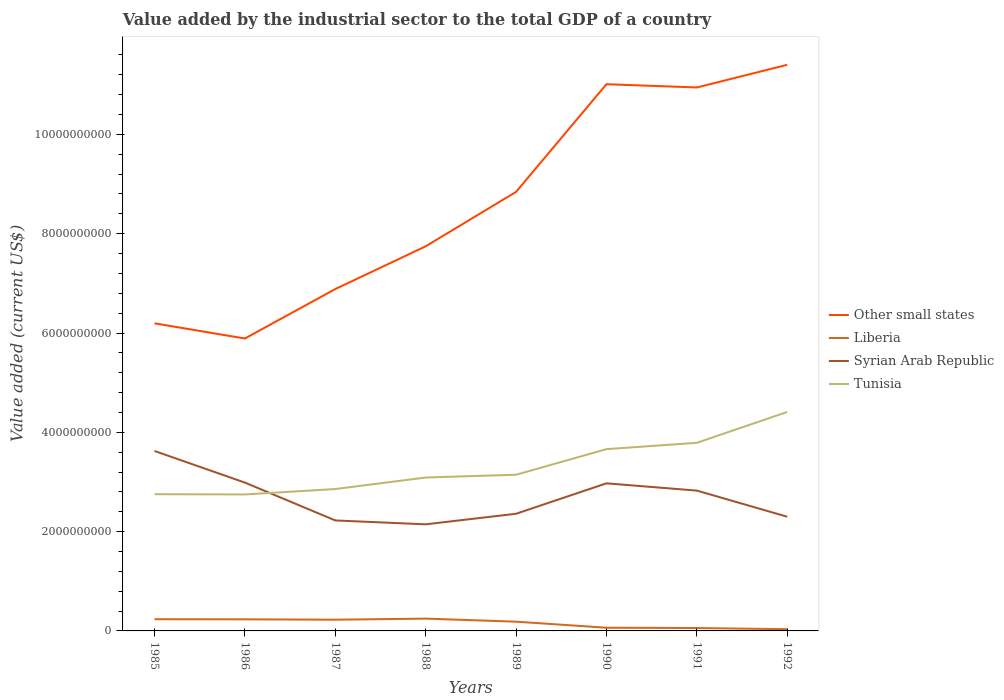How many different coloured lines are there?
Your response must be concise. 4. Does the line corresponding to Liberia intersect with the line corresponding to Syrian Arab Republic?
Your response must be concise. No. Across all years, what is the maximum value added by the industrial sector to the total GDP in Other small states?
Offer a very short reply. 5.89e+09. What is the total value added by the industrial sector to the total GDP in Syrian Arab Republic in the graph?
Your response must be concise. -8.26e+08. What is the difference between the highest and the second highest value added by the industrial sector to the total GDP in Liberia?
Make the answer very short. 2.13e+08. Is the value added by the industrial sector to the total GDP in Tunisia strictly greater than the value added by the industrial sector to the total GDP in Syrian Arab Republic over the years?
Offer a terse response. No. What is the difference between two consecutive major ticks on the Y-axis?
Give a very brief answer. 2.00e+09. Does the graph contain any zero values?
Offer a terse response. No. Does the graph contain grids?
Ensure brevity in your answer.  No. Where does the legend appear in the graph?
Your answer should be compact. Center right. How many legend labels are there?
Your answer should be compact. 4. How are the legend labels stacked?
Offer a terse response. Vertical. What is the title of the graph?
Offer a very short reply. Value added by the industrial sector to the total GDP of a country. What is the label or title of the X-axis?
Ensure brevity in your answer.  Years. What is the label or title of the Y-axis?
Provide a short and direct response. Value added (current US$). What is the Value added (current US$) in Other small states in 1985?
Offer a very short reply. 6.19e+09. What is the Value added (current US$) of Liberia in 1985?
Your response must be concise. 2.36e+08. What is the Value added (current US$) in Syrian Arab Republic in 1985?
Offer a very short reply. 3.62e+09. What is the Value added (current US$) in Tunisia in 1985?
Offer a terse response. 2.75e+09. What is the Value added (current US$) of Other small states in 1986?
Your answer should be very brief. 5.89e+09. What is the Value added (current US$) in Liberia in 1986?
Keep it short and to the point. 2.34e+08. What is the Value added (current US$) of Syrian Arab Republic in 1986?
Give a very brief answer. 2.99e+09. What is the Value added (current US$) in Tunisia in 1986?
Keep it short and to the point. 2.75e+09. What is the Value added (current US$) in Other small states in 1987?
Your response must be concise. 6.89e+09. What is the Value added (current US$) in Liberia in 1987?
Provide a short and direct response. 2.26e+08. What is the Value added (current US$) in Syrian Arab Republic in 1987?
Keep it short and to the point. 2.23e+09. What is the Value added (current US$) of Tunisia in 1987?
Provide a short and direct response. 2.86e+09. What is the Value added (current US$) of Other small states in 1988?
Your answer should be very brief. 7.75e+09. What is the Value added (current US$) of Liberia in 1988?
Provide a short and direct response. 2.48e+08. What is the Value added (current US$) of Syrian Arab Republic in 1988?
Make the answer very short. 2.15e+09. What is the Value added (current US$) in Tunisia in 1988?
Provide a short and direct response. 3.09e+09. What is the Value added (current US$) of Other small states in 1989?
Give a very brief answer. 8.84e+09. What is the Value added (current US$) of Liberia in 1989?
Offer a very short reply. 1.86e+08. What is the Value added (current US$) of Syrian Arab Republic in 1989?
Your response must be concise. 2.36e+09. What is the Value added (current US$) of Tunisia in 1989?
Offer a terse response. 3.15e+09. What is the Value added (current US$) in Other small states in 1990?
Ensure brevity in your answer.  1.10e+1. What is the Value added (current US$) of Liberia in 1990?
Your answer should be compact. 6.46e+07. What is the Value added (current US$) of Syrian Arab Republic in 1990?
Keep it short and to the point. 2.97e+09. What is the Value added (current US$) of Tunisia in 1990?
Ensure brevity in your answer.  3.66e+09. What is the Value added (current US$) in Other small states in 1991?
Provide a succinct answer. 1.09e+1. What is the Value added (current US$) in Liberia in 1991?
Keep it short and to the point. 5.83e+07. What is the Value added (current US$) in Syrian Arab Republic in 1991?
Give a very brief answer. 2.83e+09. What is the Value added (current US$) of Tunisia in 1991?
Ensure brevity in your answer.  3.79e+09. What is the Value added (current US$) of Other small states in 1992?
Your answer should be very brief. 1.14e+1. What is the Value added (current US$) of Liberia in 1992?
Keep it short and to the point. 3.49e+07. What is the Value added (current US$) in Syrian Arab Republic in 1992?
Provide a short and direct response. 2.30e+09. What is the Value added (current US$) of Tunisia in 1992?
Provide a succinct answer. 4.41e+09. Across all years, what is the maximum Value added (current US$) of Other small states?
Ensure brevity in your answer.  1.14e+1. Across all years, what is the maximum Value added (current US$) in Liberia?
Your response must be concise. 2.48e+08. Across all years, what is the maximum Value added (current US$) of Syrian Arab Republic?
Make the answer very short. 3.62e+09. Across all years, what is the maximum Value added (current US$) of Tunisia?
Provide a short and direct response. 4.41e+09. Across all years, what is the minimum Value added (current US$) of Other small states?
Ensure brevity in your answer.  5.89e+09. Across all years, what is the minimum Value added (current US$) of Liberia?
Offer a very short reply. 3.49e+07. Across all years, what is the minimum Value added (current US$) in Syrian Arab Republic?
Ensure brevity in your answer.  2.15e+09. Across all years, what is the minimum Value added (current US$) in Tunisia?
Your response must be concise. 2.75e+09. What is the total Value added (current US$) of Other small states in the graph?
Ensure brevity in your answer.  6.89e+1. What is the total Value added (current US$) in Liberia in the graph?
Make the answer very short. 1.29e+09. What is the total Value added (current US$) of Syrian Arab Republic in the graph?
Give a very brief answer. 2.14e+1. What is the total Value added (current US$) in Tunisia in the graph?
Your response must be concise. 2.65e+1. What is the difference between the Value added (current US$) in Other small states in 1985 and that in 1986?
Provide a short and direct response. 3.06e+08. What is the difference between the Value added (current US$) in Liberia in 1985 and that in 1986?
Your response must be concise. 2.39e+06. What is the difference between the Value added (current US$) in Syrian Arab Republic in 1985 and that in 1986?
Make the answer very short. 6.37e+08. What is the difference between the Value added (current US$) in Tunisia in 1985 and that in 1986?
Your response must be concise. 4.62e+06. What is the difference between the Value added (current US$) of Other small states in 1985 and that in 1987?
Offer a terse response. -6.90e+08. What is the difference between the Value added (current US$) in Liberia in 1985 and that in 1987?
Your response must be concise. 9.81e+06. What is the difference between the Value added (current US$) in Syrian Arab Republic in 1985 and that in 1987?
Keep it short and to the point. 1.40e+09. What is the difference between the Value added (current US$) of Tunisia in 1985 and that in 1987?
Keep it short and to the point. -1.04e+08. What is the difference between the Value added (current US$) of Other small states in 1985 and that in 1988?
Offer a terse response. -1.55e+09. What is the difference between the Value added (current US$) in Liberia in 1985 and that in 1988?
Provide a short and direct response. -1.18e+07. What is the difference between the Value added (current US$) in Syrian Arab Republic in 1985 and that in 1988?
Keep it short and to the point. 1.48e+09. What is the difference between the Value added (current US$) of Tunisia in 1985 and that in 1988?
Offer a very short reply. -3.36e+08. What is the difference between the Value added (current US$) of Other small states in 1985 and that in 1989?
Provide a short and direct response. -2.65e+09. What is the difference between the Value added (current US$) in Liberia in 1985 and that in 1989?
Ensure brevity in your answer.  4.98e+07. What is the difference between the Value added (current US$) of Syrian Arab Republic in 1985 and that in 1989?
Provide a succinct answer. 1.26e+09. What is the difference between the Value added (current US$) of Tunisia in 1985 and that in 1989?
Offer a very short reply. -3.92e+08. What is the difference between the Value added (current US$) in Other small states in 1985 and that in 1990?
Give a very brief answer. -4.82e+09. What is the difference between the Value added (current US$) of Liberia in 1985 and that in 1990?
Your answer should be compact. 1.71e+08. What is the difference between the Value added (current US$) of Syrian Arab Republic in 1985 and that in 1990?
Provide a short and direct response. 6.52e+08. What is the difference between the Value added (current US$) in Tunisia in 1985 and that in 1990?
Offer a very short reply. -9.08e+08. What is the difference between the Value added (current US$) in Other small states in 1985 and that in 1991?
Your answer should be compact. -4.75e+09. What is the difference between the Value added (current US$) in Liberia in 1985 and that in 1991?
Your answer should be very brief. 1.78e+08. What is the difference between the Value added (current US$) in Syrian Arab Republic in 1985 and that in 1991?
Your response must be concise. 7.98e+08. What is the difference between the Value added (current US$) of Tunisia in 1985 and that in 1991?
Keep it short and to the point. -1.04e+09. What is the difference between the Value added (current US$) of Other small states in 1985 and that in 1992?
Offer a terse response. -5.21e+09. What is the difference between the Value added (current US$) of Liberia in 1985 and that in 1992?
Your answer should be very brief. 2.01e+08. What is the difference between the Value added (current US$) of Syrian Arab Republic in 1985 and that in 1992?
Provide a short and direct response. 1.32e+09. What is the difference between the Value added (current US$) of Tunisia in 1985 and that in 1992?
Your response must be concise. -1.66e+09. What is the difference between the Value added (current US$) of Other small states in 1986 and that in 1987?
Your answer should be compact. -9.96e+08. What is the difference between the Value added (current US$) in Liberia in 1986 and that in 1987?
Provide a short and direct response. 7.42e+06. What is the difference between the Value added (current US$) of Syrian Arab Republic in 1986 and that in 1987?
Provide a short and direct response. 7.62e+08. What is the difference between the Value added (current US$) in Tunisia in 1986 and that in 1987?
Your answer should be very brief. -1.09e+08. What is the difference between the Value added (current US$) in Other small states in 1986 and that in 1988?
Provide a succinct answer. -1.86e+09. What is the difference between the Value added (current US$) of Liberia in 1986 and that in 1988?
Your answer should be compact. -1.42e+07. What is the difference between the Value added (current US$) in Syrian Arab Republic in 1986 and that in 1988?
Make the answer very short. 8.41e+08. What is the difference between the Value added (current US$) of Tunisia in 1986 and that in 1988?
Your response must be concise. -3.41e+08. What is the difference between the Value added (current US$) of Other small states in 1986 and that in 1989?
Give a very brief answer. -2.95e+09. What is the difference between the Value added (current US$) in Liberia in 1986 and that in 1989?
Offer a very short reply. 4.74e+07. What is the difference between the Value added (current US$) in Syrian Arab Republic in 1986 and that in 1989?
Provide a short and direct response. 6.28e+08. What is the difference between the Value added (current US$) in Tunisia in 1986 and that in 1989?
Give a very brief answer. -3.97e+08. What is the difference between the Value added (current US$) of Other small states in 1986 and that in 1990?
Make the answer very short. -5.12e+09. What is the difference between the Value added (current US$) of Liberia in 1986 and that in 1990?
Offer a terse response. 1.69e+08. What is the difference between the Value added (current US$) in Syrian Arab Republic in 1986 and that in 1990?
Provide a short and direct response. 1.51e+07. What is the difference between the Value added (current US$) in Tunisia in 1986 and that in 1990?
Keep it short and to the point. -9.12e+08. What is the difference between the Value added (current US$) of Other small states in 1986 and that in 1991?
Your response must be concise. -5.06e+09. What is the difference between the Value added (current US$) in Liberia in 1986 and that in 1991?
Your answer should be very brief. 1.75e+08. What is the difference between the Value added (current US$) of Syrian Arab Republic in 1986 and that in 1991?
Offer a terse response. 1.61e+08. What is the difference between the Value added (current US$) in Tunisia in 1986 and that in 1991?
Make the answer very short. -1.04e+09. What is the difference between the Value added (current US$) in Other small states in 1986 and that in 1992?
Offer a terse response. -5.51e+09. What is the difference between the Value added (current US$) in Liberia in 1986 and that in 1992?
Provide a succinct answer. 1.99e+08. What is the difference between the Value added (current US$) in Syrian Arab Republic in 1986 and that in 1992?
Offer a very short reply. 6.88e+08. What is the difference between the Value added (current US$) of Tunisia in 1986 and that in 1992?
Ensure brevity in your answer.  -1.66e+09. What is the difference between the Value added (current US$) of Other small states in 1987 and that in 1988?
Your response must be concise. -8.61e+08. What is the difference between the Value added (current US$) of Liberia in 1987 and that in 1988?
Provide a short and direct response. -2.16e+07. What is the difference between the Value added (current US$) of Syrian Arab Republic in 1987 and that in 1988?
Keep it short and to the point. 7.82e+07. What is the difference between the Value added (current US$) of Tunisia in 1987 and that in 1988?
Offer a very short reply. -2.32e+08. What is the difference between the Value added (current US$) of Other small states in 1987 and that in 1989?
Ensure brevity in your answer.  -1.96e+09. What is the difference between the Value added (current US$) in Liberia in 1987 and that in 1989?
Offer a very short reply. 4.00e+07. What is the difference between the Value added (current US$) of Syrian Arab Republic in 1987 and that in 1989?
Your answer should be very brief. -1.35e+08. What is the difference between the Value added (current US$) of Tunisia in 1987 and that in 1989?
Provide a succinct answer. -2.88e+08. What is the difference between the Value added (current US$) of Other small states in 1987 and that in 1990?
Your answer should be compact. -4.13e+09. What is the difference between the Value added (current US$) of Liberia in 1987 and that in 1990?
Ensure brevity in your answer.  1.62e+08. What is the difference between the Value added (current US$) of Syrian Arab Republic in 1987 and that in 1990?
Keep it short and to the point. -7.47e+08. What is the difference between the Value added (current US$) of Tunisia in 1987 and that in 1990?
Provide a short and direct response. -8.03e+08. What is the difference between the Value added (current US$) in Other small states in 1987 and that in 1991?
Offer a terse response. -4.06e+09. What is the difference between the Value added (current US$) in Liberia in 1987 and that in 1991?
Your answer should be very brief. 1.68e+08. What is the difference between the Value added (current US$) in Syrian Arab Republic in 1987 and that in 1991?
Give a very brief answer. -6.01e+08. What is the difference between the Value added (current US$) in Tunisia in 1987 and that in 1991?
Provide a succinct answer. -9.31e+08. What is the difference between the Value added (current US$) of Other small states in 1987 and that in 1992?
Make the answer very short. -4.52e+09. What is the difference between the Value added (current US$) in Liberia in 1987 and that in 1992?
Provide a succinct answer. 1.91e+08. What is the difference between the Value added (current US$) of Syrian Arab Republic in 1987 and that in 1992?
Provide a short and direct response. -7.48e+07. What is the difference between the Value added (current US$) in Tunisia in 1987 and that in 1992?
Ensure brevity in your answer.  -1.55e+09. What is the difference between the Value added (current US$) in Other small states in 1988 and that in 1989?
Offer a terse response. -1.10e+09. What is the difference between the Value added (current US$) of Liberia in 1988 and that in 1989?
Your answer should be compact. 6.16e+07. What is the difference between the Value added (current US$) of Syrian Arab Republic in 1988 and that in 1989?
Keep it short and to the point. -2.13e+08. What is the difference between the Value added (current US$) in Tunisia in 1988 and that in 1989?
Offer a terse response. -5.61e+07. What is the difference between the Value added (current US$) of Other small states in 1988 and that in 1990?
Offer a very short reply. -3.26e+09. What is the difference between the Value added (current US$) of Liberia in 1988 and that in 1990?
Your answer should be compact. 1.83e+08. What is the difference between the Value added (current US$) of Syrian Arab Republic in 1988 and that in 1990?
Offer a very short reply. -8.26e+08. What is the difference between the Value added (current US$) in Tunisia in 1988 and that in 1990?
Provide a short and direct response. -5.72e+08. What is the difference between the Value added (current US$) in Other small states in 1988 and that in 1991?
Offer a terse response. -3.20e+09. What is the difference between the Value added (current US$) in Liberia in 1988 and that in 1991?
Your answer should be compact. 1.90e+08. What is the difference between the Value added (current US$) of Syrian Arab Republic in 1988 and that in 1991?
Give a very brief answer. -6.79e+08. What is the difference between the Value added (current US$) of Tunisia in 1988 and that in 1991?
Keep it short and to the point. -6.99e+08. What is the difference between the Value added (current US$) in Other small states in 1988 and that in 1992?
Give a very brief answer. -3.66e+09. What is the difference between the Value added (current US$) of Liberia in 1988 and that in 1992?
Keep it short and to the point. 2.13e+08. What is the difference between the Value added (current US$) of Syrian Arab Republic in 1988 and that in 1992?
Keep it short and to the point. -1.53e+08. What is the difference between the Value added (current US$) of Tunisia in 1988 and that in 1992?
Your response must be concise. -1.32e+09. What is the difference between the Value added (current US$) in Other small states in 1989 and that in 1990?
Provide a short and direct response. -2.17e+09. What is the difference between the Value added (current US$) in Liberia in 1989 and that in 1990?
Offer a terse response. 1.22e+08. What is the difference between the Value added (current US$) in Syrian Arab Republic in 1989 and that in 1990?
Your response must be concise. -6.13e+08. What is the difference between the Value added (current US$) of Tunisia in 1989 and that in 1990?
Keep it short and to the point. -5.16e+08. What is the difference between the Value added (current US$) of Other small states in 1989 and that in 1991?
Offer a very short reply. -2.10e+09. What is the difference between the Value added (current US$) in Liberia in 1989 and that in 1991?
Ensure brevity in your answer.  1.28e+08. What is the difference between the Value added (current US$) in Syrian Arab Republic in 1989 and that in 1991?
Provide a short and direct response. -4.66e+08. What is the difference between the Value added (current US$) of Tunisia in 1989 and that in 1991?
Keep it short and to the point. -6.43e+08. What is the difference between the Value added (current US$) of Other small states in 1989 and that in 1992?
Offer a very short reply. -2.56e+09. What is the difference between the Value added (current US$) of Liberia in 1989 and that in 1992?
Your answer should be very brief. 1.51e+08. What is the difference between the Value added (current US$) in Syrian Arab Republic in 1989 and that in 1992?
Provide a short and direct response. 5.99e+07. What is the difference between the Value added (current US$) in Tunisia in 1989 and that in 1992?
Give a very brief answer. -1.26e+09. What is the difference between the Value added (current US$) in Other small states in 1990 and that in 1991?
Your answer should be compact. 6.57e+07. What is the difference between the Value added (current US$) of Liberia in 1990 and that in 1991?
Your answer should be very brief. 6.30e+06. What is the difference between the Value added (current US$) in Syrian Arab Republic in 1990 and that in 1991?
Make the answer very short. 1.46e+08. What is the difference between the Value added (current US$) of Tunisia in 1990 and that in 1991?
Make the answer very short. -1.28e+08. What is the difference between the Value added (current US$) of Other small states in 1990 and that in 1992?
Offer a very short reply. -3.91e+08. What is the difference between the Value added (current US$) in Liberia in 1990 and that in 1992?
Your response must be concise. 2.97e+07. What is the difference between the Value added (current US$) in Syrian Arab Republic in 1990 and that in 1992?
Your answer should be very brief. 6.73e+08. What is the difference between the Value added (current US$) of Tunisia in 1990 and that in 1992?
Your answer should be very brief. -7.49e+08. What is the difference between the Value added (current US$) of Other small states in 1991 and that in 1992?
Ensure brevity in your answer.  -4.57e+08. What is the difference between the Value added (current US$) of Liberia in 1991 and that in 1992?
Make the answer very short. 2.34e+07. What is the difference between the Value added (current US$) of Syrian Arab Republic in 1991 and that in 1992?
Your answer should be very brief. 5.26e+08. What is the difference between the Value added (current US$) of Tunisia in 1991 and that in 1992?
Your response must be concise. -6.22e+08. What is the difference between the Value added (current US$) in Other small states in 1985 and the Value added (current US$) in Liberia in 1986?
Offer a terse response. 5.96e+09. What is the difference between the Value added (current US$) of Other small states in 1985 and the Value added (current US$) of Syrian Arab Republic in 1986?
Offer a very short reply. 3.21e+09. What is the difference between the Value added (current US$) of Other small states in 1985 and the Value added (current US$) of Tunisia in 1986?
Make the answer very short. 3.45e+09. What is the difference between the Value added (current US$) of Liberia in 1985 and the Value added (current US$) of Syrian Arab Republic in 1986?
Offer a terse response. -2.75e+09. What is the difference between the Value added (current US$) in Liberia in 1985 and the Value added (current US$) in Tunisia in 1986?
Keep it short and to the point. -2.51e+09. What is the difference between the Value added (current US$) in Syrian Arab Republic in 1985 and the Value added (current US$) in Tunisia in 1986?
Your answer should be very brief. 8.75e+08. What is the difference between the Value added (current US$) of Other small states in 1985 and the Value added (current US$) of Liberia in 1987?
Give a very brief answer. 5.97e+09. What is the difference between the Value added (current US$) in Other small states in 1985 and the Value added (current US$) in Syrian Arab Republic in 1987?
Make the answer very short. 3.97e+09. What is the difference between the Value added (current US$) in Other small states in 1985 and the Value added (current US$) in Tunisia in 1987?
Your answer should be compact. 3.34e+09. What is the difference between the Value added (current US$) in Liberia in 1985 and the Value added (current US$) in Syrian Arab Republic in 1987?
Offer a terse response. -1.99e+09. What is the difference between the Value added (current US$) in Liberia in 1985 and the Value added (current US$) in Tunisia in 1987?
Offer a terse response. -2.62e+09. What is the difference between the Value added (current US$) in Syrian Arab Republic in 1985 and the Value added (current US$) in Tunisia in 1987?
Offer a terse response. 7.66e+08. What is the difference between the Value added (current US$) in Other small states in 1985 and the Value added (current US$) in Liberia in 1988?
Your answer should be compact. 5.95e+09. What is the difference between the Value added (current US$) of Other small states in 1985 and the Value added (current US$) of Syrian Arab Republic in 1988?
Make the answer very short. 4.05e+09. What is the difference between the Value added (current US$) in Other small states in 1985 and the Value added (current US$) in Tunisia in 1988?
Offer a terse response. 3.11e+09. What is the difference between the Value added (current US$) in Liberia in 1985 and the Value added (current US$) in Syrian Arab Republic in 1988?
Keep it short and to the point. -1.91e+09. What is the difference between the Value added (current US$) of Liberia in 1985 and the Value added (current US$) of Tunisia in 1988?
Offer a terse response. -2.85e+09. What is the difference between the Value added (current US$) in Syrian Arab Republic in 1985 and the Value added (current US$) in Tunisia in 1988?
Offer a very short reply. 5.35e+08. What is the difference between the Value added (current US$) of Other small states in 1985 and the Value added (current US$) of Liberia in 1989?
Provide a succinct answer. 6.01e+09. What is the difference between the Value added (current US$) of Other small states in 1985 and the Value added (current US$) of Syrian Arab Republic in 1989?
Provide a succinct answer. 3.84e+09. What is the difference between the Value added (current US$) of Other small states in 1985 and the Value added (current US$) of Tunisia in 1989?
Offer a terse response. 3.05e+09. What is the difference between the Value added (current US$) in Liberia in 1985 and the Value added (current US$) in Syrian Arab Republic in 1989?
Your answer should be very brief. -2.12e+09. What is the difference between the Value added (current US$) in Liberia in 1985 and the Value added (current US$) in Tunisia in 1989?
Ensure brevity in your answer.  -2.91e+09. What is the difference between the Value added (current US$) of Syrian Arab Republic in 1985 and the Value added (current US$) of Tunisia in 1989?
Make the answer very short. 4.79e+08. What is the difference between the Value added (current US$) in Other small states in 1985 and the Value added (current US$) in Liberia in 1990?
Provide a succinct answer. 6.13e+09. What is the difference between the Value added (current US$) in Other small states in 1985 and the Value added (current US$) in Syrian Arab Republic in 1990?
Make the answer very short. 3.22e+09. What is the difference between the Value added (current US$) in Other small states in 1985 and the Value added (current US$) in Tunisia in 1990?
Provide a succinct answer. 2.53e+09. What is the difference between the Value added (current US$) in Liberia in 1985 and the Value added (current US$) in Syrian Arab Republic in 1990?
Your answer should be compact. -2.74e+09. What is the difference between the Value added (current US$) of Liberia in 1985 and the Value added (current US$) of Tunisia in 1990?
Your answer should be compact. -3.43e+09. What is the difference between the Value added (current US$) of Syrian Arab Republic in 1985 and the Value added (current US$) of Tunisia in 1990?
Provide a short and direct response. -3.69e+07. What is the difference between the Value added (current US$) of Other small states in 1985 and the Value added (current US$) of Liberia in 1991?
Give a very brief answer. 6.14e+09. What is the difference between the Value added (current US$) of Other small states in 1985 and the Value added (current US$) of Syrian Arab Republic in 1991?
Offer a terse response. 3.37e+09. What is the difference between the Value added (current US$) of Other small states in 1985 and the Value added (current US$) of Tunisia in 1991?
Give a very brief answer. 2.41e+09. What is the difference between the Value added (current US$) of Liberia in 1985 and the Value added (current US$) of Syrian Arab Republic in 1991?
Your answer should be compact. -2.59e+09. What is the difference between the Value added (current US$) in Liberia in 1985 and the Value added (current US$) in Tunisia in 1991?
Make the answer very short. -3.55e+09. What is the difference between the Value added (current US$) of Syrian Arab Republic in 1985 and the Value added (current US$) of Tunisia in 1991?
Offer a very short reply. -1.64e+08. What is the difference between the Value added (current US$) in Other small states in 1985 and the Value added (current US$) in Liberia in 1992?
Your response must be concise. 6.16e+09. What is the difference between the Value added (current US$) of Other small states in 1985 and the Value added (current US$) of Syrian Arab Republic in 1992?
Offer a very short reply. 3.89e+09. What is the difference between the Value added (current US$) of Other small states in 1985 and the Value added (current US$) of Tunisia in 1992?
Your response must be concise. 1.78e+09. What is the difference between the Value added (current US$) of Liberia in 1985 and the Value added (current US$) of Syrian Arab Republic in 1992?
Ensure brevity in your answer.  -2.06e+09. What is the difference between the Value added (current US$) in Liberia in 1985 and the Value added (current US$) in Tunisia in 1992?
Offer a very short reply. -4.17e+09. What is the difference between the Value added (current US$) of Syrian Arab Republic in 1985 and the Value added (current US$) of Tunisia in 1992?
Your answer should be very brief. -7.86e+08. What is the difference between the Value added (current US$) of Other small states in 1986 and the Value added (current US$) of Liberia in 1987?
Your response must be concise. 5.66e+09. What is the difference between the Value added (current US$) of Other small states in 1986 and the Value added (current US$) of Syrian Arab Republic in 1987?
Provide a succinct answer. 3.66e+09. What is the difference between the Value added (current US$) of Other small states in 1986 and the Value added (current US$) of Tunisia in 1987?
Keep it short and to the point. 3.03e+09. What is the difference between the Value added (current US$) of Liberia in 1986 and the Value added (current US$) of Syrian Arab Republic in 1987?
Make the answer very short. -1.99e+09. What is the difference between the Value added (current US$) of Liberia in 1986 and the Value added (current US$) of Tunisia in 1987?
Provide a succinct answer. -2.62e+09. What is the difference between the Value added (current US$) of Syrian Arab Republic in 1986 and the Value added (current US$) of Tunisia in 1987?
Offer a terse response. 1.30e+08. What is the difference between the Value added (current US$) of Other small states in 1986 and the Value added (current US$) of Liberia in 1988?
Offer a terse response. 5.64e+09. What is the difference between the Value added (current US$) of Other small states in 1986 and the Value added (current US$) of Syrian Arab Republic in 1988?
Make the answer very short. 3.74e+09. What is the difference between the Value added (current US$) in Other small states in 1986 and the Value added (current US$) in Tunisia in 1988?
Your answer should be compact. 2.80e+09. What is the difference between the Value added (current US$) of Liberia in 1986 and the Value added (current US$) of Syrian Arab Republic in 1988?
Offer a terse response. -1.91e+09. What is the difference between the Value added (current US$) of Liberia in 1986 and the Value added (current US$) of Tunisia in 1988?
Keep it short and to the point. -2.86e+09. What is the difference between the Value added (current US$) in Syrian Arab Republic in 1986 and the Value added (current US$) in Tunisia in 1988?
Ensure brevity in your answer.  -1.02e+08. What is the difference between the Value added (current US$) in Other small states in 1986 and the Value added (current US$) in Liberia in 1989?
Ensure brevity in your answer.  5.70e+09. What is the difference between the Value added (current US$) in Other small states in 1986 and the Value added (current US$) in Syrian Arab Republic in 1989?
Ensure brevity in your answer.  3.53e+09. What is the difference between the Value added (current US$) of Other small states in 1986 and the Value added (current US$) of Tunisia in 1989?
Your response must be concise. 2.74e+09. What is the difference between the Value added (current US$) of Liberia in 1986 and the Value added (current US$) of Syrian Arab Republic in 1989?
Your answer should be very brief. -2.13e+09. What is the difference between the Value added (current US$) of Liberia in 1986 and the Value added (current US$) of Tunisia in 1989?
Keep it short and to the point. -2.91e+09. What is the difference between the Value added (current US$) of Syrian Arab Republic in 1986 and the Value added (current US$) of Tunisia in 1989?
Offer a very short reply. -1.58e+08. What is the difference between the Value added (current US$) in Other small states in 1986 and the Value added (current US$) in Liberia in 1990?
Provide a short and direct response. 5.82e+09. What is the difference between the Value added (current US$) of Other small states in 1986 and the Value added (current US$) of Syrian Arab Republic in 1990?
Offer a terse response. 2.92e+09. What is the difference between the Value added (current US$) of Other small states in 1986 and the Value added (current US$) of Tunisia in 1990?
Keep it short and to the point. 2.23e+09. What is the difference between the Value added (current US$) in Liberia in 1986 and the Value added (current US$) in Syrian Arab Republic in 1990?
Your response must be concise. -2.74e+09. What is the difference between the Value added (current US$) in Liberia in 1986 and the Value added (current US$) in Tunisia in 1990?
Your answer should be very brief. -3.43e+09. What is the difference between the Value added (current US$) in Syrian Arab Republic in 1986 and the Value added (current US$) in Tunisia in 1990?
Make the answer very short. -6.74e+08. What is the difference between the Value added (current US$) of Other small states in 1986 and the Value added (current US$) of Liberia in 1991?
Your response must be concise. 5.83e+09. What is the difference between the Value added (current US$) in Other small states in 1986 and the Value added (current US$) in Syrian Arab Republic in 1991?
Keep it short and to the point. 3.06e+09. What is the difference between the Value added (current US$) in Other small states in 1986 and the Value added (current US$) in Tunisia in 1991?
Offer a terse response. 2.10e+09. What is the difference between the Value added (current US$) in Liberia in 1986 and the Value added (current US$) in Syrian Arab Republic in 1991?
Offer a very short reply. -2.59e+09. What is the difference between the Value added (current US$) of Liberia in 1986 and the Value added (current US$) of Tunisia in 1991?
Give a very brief answer. -3.56e+09. What is the difference between the Value added (current US$) of Syrian Arab Republic in 1986 and the Value added (current US$) of Tunisia in 1991?
Offer a very short reply. -8.01e+08. What is the difference between the Value added (current US$) in Other small states in 1986 and the Value added (current US$) in Liberia in 1992?
Ensure brevity in your answer.  5.85e+09. What is the difference between the Value added (current US$) in Other small states in 1986 and the Value added (current US$) in Syrian Arab Republic in 1992?
Your answer should be very brief. 3.59e+09. What is the difference between the Value added (current US$) in Other small states in 1986 and the Value added (current US$) in Tunisia in 1992?
Your answer should be compact. 1.48e+09. What is the difference between the Value added (current US$) in Liberia in 1986 and the Value added (current US$) in Syrian Arab Republic in 1992?
Your answer should be very brief. -2.07e+09. What is the difference between the Value added (current US$) of Liberia in 1986 and the Value added (current US$) of Tunisia in 1992?
Your response must be concise. -4.18e+09. What is the difference between the Value added (current US$) of Syrian Arab Republic in 1986 and the Value added (current US$) of Tunisia in 1992?
Your response must be concise. -1.42e+09. What is the difference between the Value added (current US$) in Other small states in 1987 and the Value added (current US$) in Liberia in 1988?
Make the answer very short. 6.64e+09. What is the difference between the Value added (current US$) of Other small states in 1987 and the Value added (current US$) of Syrian Arab Republic in 1988?
Give a very brief answer. 4.74e+09. What is the difference between the Value added (current US$) of Other small states in 1987 and the Value added (current US$) of Tunisia in 1988?
Make the answer very short. 3.80e+09. What is the difference between the Value added (current US$) in Liberia in 1987 and the Value added (current US$) in Syrian Arab Republic in 1988?
Give a very brief answer. -1.92e+09. What is the difference between the Value added (current US$) in Liberia in 1987 and the Value added (current US$) in Tunisia in 1988?
Offer a very short reply. -2.86e+09. What is the difference between the Value added (current US$) of Syrian Arab Republic in 1987 and the Value added (current US$) of Tunisia in 1988?
Offer a very short reply. -8.64e+08. What is the difference between the Value added (current US$) in Other small states in 1987 and the Value added (current US$) in Liberia in 1989?
Your answer should be very brief. 6.70e+09. What is the difference between the Value added (current US$) of Other small states in 1987 and the Value added (current US$) of Syrian Arab Republic in 1989?
Give a very brief answer. 4.53e+09. What is the difference between the Value added (current US$) in Other small states in 1987 and the Value added (current US$) in Tunisia in 1989?
Keep it short and to the point. 3.74e+09. What is the difference between the Value added (current US$) in Liberia in 1987 and the Value added (current US$) in Syrian Arab Republic in 1989?
Your answer should be compact. -2.13e+09. What is the difference between the Value added (current US$) of Liberia in 1987 and the Value added (current US$) of Tunisia in 1989?
Provide a short and direct response. -2.92e+09. What is the difference between the Value added (current US$) in Syrian Arab Republic in 1987 and the Value added (current US$) in Tunisia in 1989?
Offer a very short reply. -9.20e+08. What is the difference between the Value added (current US$) of Other small states in 1987 and the Value added (current US$) of Liberia in 1990?
Your answer should be very brief. 6.82e+09. What is the difference between the Value added (current US$) in Other small states in 1987 and the Value added (current US$) in Syrian Arab Republic in 1990?
Ensure brevity in your answer.  3.91e+09. What is the difference between the Value added (current US$) in Other small states in 1987 and the Value added (current US$) in Tunisia in 1990?
Keep it short and to the point. 3.22e+09. What is the difference between the Value added (current US$) in Liberia in 1987 and the Value added (current US$) in Syrian Arab Republic in 1990?
Offer a very short reply. -2.75e+09. What is the difference between the Value added (current US$) of Liberia in 1987 and the Value added (current US$) of Tunisia in 1990?
Your answer should be very brief. -3.43e+09. What is the difference between the Value added (current US$) in Syrian Arab Republic in 1987 and the Value added (current US$) in Tunisia in 1990?
Keep it short and to the point. -1.44e+09. What is the difference between the Value added (current US$) of Other small states in 1987 and the Value added (current US$) of Liberia in 1991?
Make the answer very short. 6.83e+09. What is the difference between the Value added (current US$) of Other small states in 1987 and the Value added (current US$) of Syrian Arab Republic in 1991?
Ensure brevity in your answer.  4.06e+09. What is the difference between the Value added (current US$) of Other small states in 1987 and the Value added (current US$) of Tunisia in 1991?
Make the answer very short. 3.10e+09. What is the difference between the Value added (current US$) of Liberia in 1987 and the Value added (current US$) of Syrian Arab Republic in 1991?
Your answer should be very brief. -2.60e+09. What is the difference between the Value added (current US$) of Liberia in 1987 and the Value added (current US$) of Tunisia in 1991?
Your answer should be very brief. -3.56e+09. What is the difference between the Value added (current US$) of Syrian Arab Republic in 1987 and the Value added (current US$) of Tunisia in 1991?
Offer a very short reply. -1.56e+09. What is the difference between the Value added (current US$) of Other small states in 1987 and the Value added (current US$) of Liberia in 1992?
Provide a succinct answer. 6.85e+09. What is the difference between the Value added (current US$) of Other small states in 1987 and the Value added (current US$) of Syrian Arab Republic in 1992?
Offer a terse response. 4.59e+09. What is the difference between the Value added (current US$) in Other small states in 1987 and the Value added (current US$) in Tunisia in 1992?
Make the answer very short. 2.48e+09. What is the difference between the Value added (current US$) in Liberia in 1987 and the Value added (current US$) in Syrian Arab Republic in 1992?
Your answer should be very brief. -2.07e+09. What is the difference between the Value added (current US$) in Liberia in 1987 and the Value added (current US$) in Tunisia in 1992?
Give a very brief answer. -4.18e+09. What is the difference between the Value added (current US$) in Syrian Arab Republic in 1987 and the Value added (current US$) in Tunisia in 1992?
Make the answer very short. -2.19e+09. What is the difference between the Value added (current US$) of Other small states in 1988 and the Value added (current US$) of Liberia in 1989?
Ensure brevity in your answer.  7.56e+09. What is the difference between the Value added (current US$) of Other small states in 1988 and the Value added (current US$) of Syrian Arab Republic in 1989?
Offer a terse response. 5.39e+09. What is the difference between the Value added (current US$) in Other small states in 1988 and the Value added (current US$) in Tunisia in 1989?
Provide a succinct answer. 4.60e+09. What is the difference between the Value added (current US$) in Liberia in 1988 and the Value added (current US$) in Syrian Arab Republic in 1989?
Provide a short and direct response. -2.11e+09. What is the difference between the Value added (current US$) in Liberia in 1988 and the Value added (current US$) in Tunisia in 1989?
Your response must be concise. -2.90e+09. What is the difference between the Value added (current US$) in Syrian Arab Republic in 1988 and the Value added (current US$) in Tunisia in 1989?
Provide a succinct answer. -9.99e+08. What is the difference between the Value added (current US$) in Other small states in 1988 and the Value added (current US$) in Liberia in 1990?
Your response must be concise. 7.68e+09. What is the difference between the Value added (current US$) of Other small states in 1988 and the Value added (current US$) of Syrian Arab Republic in 1990?
Your answer should be very brief. 4.77e+09. What is the difference between the Value added (current US$) of Other small states in 1988 and the Value added (current US$) of Tunisia in 1990?
Make the answer very short. 4.09e+09. What is the difference between the Value added (current US$) in Liberia in 1988 and the Value added (current US$) in Syrian Arab Republic in 1990?
Provide a succinct answer. -2.72e+09. What is the difference between the Value added (current US$) of Liberia in 1988 and the Value added (current US$) of Tunisia in 1990?
Offer a very short reply. -3.41e+09. What is the difference between the Value added (current US$) in Syrian Arab Republic in 1988 and the Value added (current US$) in Tunisia in 1990?
Keep it short and to the point. -1.51e+09. What is the difference between the Value added (current US$) in Other small states in 1988 and the Value added (current US$) in Liberia in 1991?
Give a very brief answer. 7.69e+09. What is the difference between the Value added (current US$) of Other small states in 1988 and the Value added (current US$) of Syrian Arab Republic in 1991?
Keep it short and to the point. 4.92e+09. What is the difference between the Value added (current US$) in Other small states in 1988 and the Value added (current US$) in Tunisia in 1991?
Your response must be concise. 3.96e+09. What is the difference between the Value added (current US$) in Liberia in 1988 and the Value added (current US$) in Syrian Arab Republic in 1991?
Make the answer very short. -2.58e+09. What is the difference between the Value added (current US$) of Liberia in 1988 and the Value added (current US$) of Tunisia in 1991?
Provide a short and direct response. -3.54e+09. What is the difference between the Value added (current US$) in Syrian Arab Republic in 1988 and the Value added (current US$) in Tunisia in 1991?
Make the answer very short. -1.64e+09. What is the difference between the Value added (current US$) in Other small states in 1988 and the Value added (current US$) in Liberia in 1992?
Make the answer very short. 7.71e+09. What is the difference between the Value added (current US$) of Other small states in 1988 and the Value added (current US$) of Syrian Arab Republic in 1992?
Keep it short and to the point. 5.45e+09. What is the difference between the Value added (current US$) of Other small states in 1988 and the Value added (current US$) of Tunisia in 1992?
Provide a short and direct response. 3.34e+09. What is the difference between the Value added (current US$) in Liberia in 1988 and the Value added (current US$) in Syrian Arab Republic in 1992?
Your answer should be compact. -2.05e+09. What is the difference between the Value added (current US$) in Liberia in 1988 and the Value added (current US$) in Tunisia in 1992?
Make the answer very short. -4.16e+09. What is the difference between the Value added (current US$) in Syrian Arab Republic in 1988 and the Value added (current US$) in Tunisia in 1992?
Your answer should be compact. -2.26e+09. What is the difference between the Value added (current US$) in Other small states in 1989 and the Value added (current US$) in Liberia in 1990?
Make the answer very short. 8.78e+09. What is the difference between the Value added (current US$) in Other small states in 1989 and the Value added (current US$) in Syrian Arab Republic in 1990?
Provide a short and direct response. 5.87e+09. What is the difference between the Value added (current US$) in Other small states in 1989 and the Value added (current US$) in Tunisia in 1990?
Your answer should be compact. 5.18e+09. What is the difference between the Value added (current US$) in Liberia in 1989 and the Value added (current US$) in Syrian Arab Republic in 1990?
Your answer should be very brief. -2.79e+09. What is the difference between the Value added (current US$) in Liberia in 1989 and the Value added (current US$) in Tunisia in 1990?
Offer a terse response. -3.47e+09. What is the difference between the Value added (current US$) in Syrian Arab Republic in 1989 and the Value added (current US$) in Tunisia in 1990?
Provide a succinct answer. -1.30e+09. What is the difference between the Value added (current US$) in Other small states in 1989 and the Value added (current US$) in Liberia in 1991?
Make the answer very short. 8.78e+09. What is the difference between the Value added (current US$) of Other small states in 1989 and the Value added (current US$) of Syrian Arab Republic in 1991?
Offer a terse response. 6.02e+09. What is the difference between the Value added (current US$) in Other small states in 1989 and the Value added (current US$) in Tunisia in 1991?
Your response must be concise. 5.05e+09. What is the difference between the Value added (current US$) of Liberia in 1989 and the Value added (current US$) of Syrian Arab Republic in 1991?
Offer a terse response. -2.64e+09. What is the difference between the Value added (current US$) in Liberia in 1989 and the Value added (current US$) in Tunisia in 1991?
Your answer should be compact. -3.60e+09. What is the difference between the Value added (current US$) of Syrian Arab Republic in 1989 and the Value added (current US$) of Tunisia in 1991?
Your answer should be compact. -1.43e+09. What is the difference between the Value added (current US$) of Other small states in 1989 and the Value added (current US$) of Liberia in 1992?
Offer a terse response. 8.81e+09. What is the difference between the Value added (current US$) in Other small states in 1989 and the Value added (current US$) in Syrian Arab Republic in 1992?
Your answer should be compact. 6.54e+09. What is the difference between the Value added (current US$) of Other small states in 1989 and the Value added (current US$) of Tunisia in 1992?
Offer a very short reply. 4.43e+09. What is the difference between the Value added (current US$) in Liberia in 1989 and the Value added (current US$) in Syrian Arab Republic in 1992?
Make the answer very short. -2.11e+09. What is the difference between the Value added (current US$) in Liberia in 1989 and the Value added (current US$) in Tunisia in 1992?
Your answer should be very brief. -4.22e+09. What is the difference between the Value added (current US$) of Syrian Arab Republic in 1989 and the Value added (current US$) of Tunisia in 1992?
Give a very brief answer. -2.05e+09. What is the difference between the Value added (current US$) in Other small states in 1990 and the Value added (current US$) in Liberia in 1991?
Make the answer very short. 1.10e+1. What is the difference between the Value added (current US$) of Other small states in 1990 and the Value added (current US$) of Syrian Arab Republic in 1991?
Provide a short and direct response. 8.18e+09. What is the difference between the Value added (current US$) in Other small states in 1990 and the Value added (current US$) in Tunisia in 1991?
Give a very brief answer. 7.22e+09. What is the difference between the Value added (current US$) in Liberia in 1990 and the Value added (current US$) in Syrian Arab Republic in 1991?
Keep it short and to the point. -2.76e+09. What is the difference between the Value added (current US$) in Liberia in 1990 and the Value added (current US$) in Tunisia in 1991?
Give a very brief answer. -3.72e+09. What is the difference between the Value added (current US$) in Syrian Arab Republic in 1990 and the Value added (current US$) in Tunisia in 1991?
Offer a very short reply. -8.16e+08. What is the difference between the Value added (current US$) of Other small states in 1990 and the Value added (current US$) of Liberia in 1992?
Keep it short and to the point. 1.10e+1. What is the difference between the Value added (current US$) in Other small states in 1990 and the Value added (current US$) in Syrian Arab Republic in 1992?
Your answer should be very brief. 8.71e+09. What is the difference between the Value added (current US$) in Other small states in 1990 and the Value added (current US$) in Tunisia in 1992?
Offer a very short reply. 6.60e+09. What is the difference between the Value added (current US$) of Liberia in 1990 and the Value added (current US$) of Syrian Arab Republic in 1992?
Offer a terse response. -2.24e+09. What is the difference between the Value added (current US$) in Liberia in 1990 and the Value added (current US$) in Tunisia in 1992?
Keep it short and to the point. -4.35e+09. What is the difference between the Value added (current US$) of Syrian Arab Republic in 1990 and the Value added (current US$) of Tunisia in 1992?
Give a very brief answer. -1.44e+09. What is the difference between the Value added (current US$) of Other small states in 1991 and the Value added (current US$) of Liberia in 1992?
Ensure brevity in your answer.  1.09e+1. What is the difference between the Value added (current US$) in Other small states in 1991 and the Value added (current US$) in Syrian Arab Republic in 1992?
Make the answer very short. 8.65e+09. What is the difference between the Value added (current US$) of Other small states in 1991 and the Value added (current US$) of Tunisia in 1992?
Make the answer very short. 6.54e+09. What is the difference between the Value added (current US$) of Liberia in 1991 and the Value added (current US$) of Syrian Arab Republic in 1992?
Ensure brevity in your answer.  -2.24e+09. What is the difference between the Value added (current US$) in Liberia in 1991 and the Value added (current US$) in Tunisia in 1992?
Provide a short and direct response. -4.35e+09. What is the difference between the Value added (current US$) of Syrian Arab Republic in 1991 and the Value added (current US$) of Tunisia in 1992?
Give a very brief answer. -1.58e+09. What is the average Value added (current US$) of Other small states per year?
Give a very brief answer. 8.61e+09. What is the average Value added (current US$) of Liberia per year?
Provide a succinct answer. 1.61e+08. What is the average Value added (current US$) in Syrian Arab Republic per year?
Provide a succinct answer. 2.68e+09. What is the average Value added (current US$) in Tunisia per year?
Offer a very short reply. 3.31e+09. In the year 1985, what is the difference between the Value added (current US$) in Other small states and Value added (current US$) in Liberia?
Your response must be concise. 5.96e+09. In the year 1985, what is the difference between the Value added (current US$) of Other small states and Value added (current US$) of Syrian Arab Republic?
Provide a succinct answer. 2.57e+09. In the year 1985, what is the difference between the Value added (current US$) of Other small states and Value added (current US$) of Tunisia?
Provide a short and direct response. 3.44e+09. In the year 1985, what is the difference between the Value added (current US$) of Liberia and Value added (current US$) of Syrian Arab Republic?
Provide a short and direct response. -3.39e+09. In the year 1985, what is the difference between the Value added (current US$) in Liberia and Value added (current US$) in Tunisia?
Your response must be concise. -2.52e+09. In the year 1985, what is the difference between the Value added (current US$) of Syrian Arab Republic and Value added (current US$) of Tunisia?
Provide a short and direct response. 8.71e+08. In the year 1986, what is the difference between the Value added (current US$) of Other small states and Value added (current US$) of Liberia?
Provide a short and direct response. 5.66e+09. In the year 1986, what is the difference between the Value added (current US$) of Other small states and Value added (current US$) of Syrian Arab Republic?
Offer a very short reply. 2.90e+09. In the year 1986, what is the difference between the Value added (current US$) in Other small states and Value added (current US$) in Tunisia?
Make the answer very short. 3.14e+09. In the year 1986, what is the difference between the Value added (current US$) in Liberia and Value added (current US$) in Syrian Arab Republic?
Offer a very short reply. -2.75e+09. In the year 1986, what is the difference between the Value added (current US$) of Liberia and Value added (current US$) of Tunisia?
Your answer should be compact. -2.52e+09. In the year 1986, what is the difference between the Value added (current US$) of Syrian Arab Republic and Value added (current US$) of Tunisia?
Give a very brief answer. 2.39e+08. In the year 1987, what is the difference between the Value added (current US$) of Other small states and Value added (current US$) of Liberia?
Ensure brevity in your answer.  6.66e+09. In the year 1987, what is the difference between the Value added (current US$) of Other small states and Value added (current US$) of Syrian Arab Republic?
Your response must be concise. 4.66e+09. In the year 1987, what is the difference between the Value added (current US$) of Other small states and Value added (current US$) of Tunisia?
Your answer should be very brief. 4.03e+09. In the year 1987, what is the difference between the Value added (current US$) of Liberia and Value added (current US$) of Syrian Arab Republic?
Make the answer very short. -2.00e+09. In the year 1987, what is the difference between the Value added (current US$) in Liberia and Value added (current US$) in Tunisia?
Offer a terse response. -2.63e+09. In the year 1987, what is the difference between the Value added (current US$) in Syrian Arab Republic and Value added (current US$) in Tunisia?
Offer a very short reply. -6.33e+08. In the year 1988, what is the difference between the Value added (current US$) of Other small states and Value added (current US$) of Liberia?
Give a very brief answer. 7.50e+09. In the year 1988, what is the difference between the Value added (current US$) of Other small states and Value added (current US$) of Syrian Arab Republic?
Make the answer very short. 5.60e+09. In the year 1988, what is the difference between the Value added (current US$) in Other small states and Value added (current US$) in Tunisia?
Ensure brevity in your answer.  4.66e+09. In the year 1988, what is the difference between the Value added (current US$) in Liberia and Value added (current US$) in Syrian Arab Republic?
Keep it short and to the point. -1.90e+09. In the year 1988, what is the difference between the Value added (current US$) in Liberia and Value added (current US$) in Tunisia?
Your answer should be very brief. -2.84e+09. In the year 1988, what is the difference between the Value added (current US$) of Syrian Arab Republic and Value added (current US$) of Tunisia?
Your answer should be compact. -9.43e+08. In the year 1989, what is the difference between the Value added (current US$) of Other small states and Value added (current US$) of Liberia?
Your answer should be compact. 8.66e+09. In the year 1989, what is the difference between the Value added (current US$) of Other small states and Value added (current US$) of Syrian Arab Republic?
Keep it short and to the point. 6.48e+09. In the year 1989, what is the difference between the Value added (current US$) in Other small states and Value added (current US$) in Tunisia?
Keep it short and to the point. 5.70e+09. In the year 1989, what is the difference between the Value added (current US$) in Liberia and Value added (current US$) in Syrian Arab Republic?
Your response must be concise. -2.17e+09. In the year 1989, what is the difference between the Value added (current US$) in Liberia and Value added (current US$) in Tunisia?
Make the answer very short. -2.96e+09. In the year 1989, what is the difference between the Value added (current US$) of Syrian Arab Republic and Value added (current US$) of Tunisia?
Ensure brevity in your answer.  -7.86e+08. In the year 1990, what is the difference between the Value added (current US$) of Other small states and Value added (current US$) of Liberia?
Provide a succinct answer. 1.09e+1. In the year 1990, what is the difference between the Value added (current US$) in Other small states and Value added (current US$) in Syrian Arab Republic?
Provide a short and direct response. 8.04e+09. In the year 1990, what is the difference between the Value added (current US$) of Other small states and Value added (current US$) of Tunisia?
Your response must be concise. 7.35e+09. In the year 1990, what is the difference between the Value added (current US$) of Liberia and Value added (current US$) of Syrian Arab Republic?
Your response must be concise. -2.91e+09. In the year 1990, what is the difference between the Value added (current US$) in Liberia and Value added (current US$) in Tunisia?
Ensure brevity in your answer.  -3.60e+09. In the year 1990, what is the difference between the Value added (current US$) in Syrian Arab Republic and Value added (current US$) in Tunisia?
Your answer should be very brief. -6.89e+08. In the year 1991, what is the difference between the Value added (current US$) in Other small states and Value added (current US$) in Liberia?
Keep it short and to the point. 1.09e+1. In the year 1991, what is the difference between the Value added (current US$) in Other small states and Value added (current US$) in Syrian Arab Republic?
Keep it short and to the point. 8.12e+09. In the year 1991, what is the difference between the Value added (current US$) in Other small states and Value added (current US$) in Tunisia?
Provide a succinct answer. 7.16e+09. In the year 1991, what is the difference between the Value added (current US$) in Liberia and Value added (current US$) in Syrian Arab Republic?
Your answer should be very brief. -2.77e+09. In the year 1991, what is the difference between the Value added (current US$) of Liberia and Value added (current US$) of Tunisia?
Provide a short and direct response. -3.73e+09. In the year 1991, what is the difference between the Value added (current US$) in Syrian Arab Republic and Value added (current US$) in Tunisia?
Keep it short and to the point. -9.63e+08. In the year 1992, what is the difference between the Value added (current US$) in Other small states and Value added (current US$) in Liberia?
Give a very brief answer. 1.14e+1. In the year 1992, what is the difference between the Value added (current US$) of Other small states and Value added (current US$) of Syrian Arab Republic?
Keep it short and to the point. 9.10e+09. In the year 1992, what is the difference between the Value added (current US$) in Other small states and Value added (current US$) in Tunisia?
Ensure brevity in your answer.  6.99e+09. In the year 1992, what is the difference between the Value added (current US$) of Liberia and Value added (current US$) of Syrian Arab Republic?
Your answer should be compact. -2.27e+09. In the year 1992, what is the difference between the Value added (current US$) of Liberia and Value added (current US$) of Tunisia?
Your answer should be compact. -4.38e+09. In the year 1992, what is the difference between the Value added (current US$) in Syrian Arab Republic and Value added (current US$) in Tunisia?
Keep it short and to the point. -2.11e+09. What is the ratio of the Value added (current US$) of Other small states in 1985 to that in 1986?
Your response must be concise. 1.05. What is the ratio of the Value added (current US$) of Liberia in 1985 to that in 1986?
Your answer should be compact. 1.01. What is the ratio of the Value added (current US$) of Syrian Arab Republic in 1985 to that in 1986?
Your answer should be compact. 1.21. What is the ratio of the Value added (current US$) of Other small states in 1985 to that in 1987?
Your answer should be compact. 0.9. What is the ratio of the Value added (current US$) of Liberia in 1985 to that in 1987?
Give a very brief answer. 1.04. What is the ratio of the Value added (current US$) in Syrian Arab Republic in 1985 to that in 1987?
Ensure brevity in your answer.  1.63. What is the ratio of the Value added (current US$) of Tunisia in 1985 to that in 1987?
Ensure brevity in your answer.  0.96. What is the ratio of the Value added (current US$) in Other small states in 1985 to that in 1988?
Your answer should be very brief. 0.8. What is the ratio of the Value added (current US$) of Syrian Arab Republic in 1985 to that in 1988?
Make the answer very short. 1.69. What is the ratio of the Value added (current US$) of Tunisia in 1985 to that in 1988?
Provide a short and direct response. 0.89. What is the ratio of the Value added (current US$) of Other small states in 1985 to that in 1989?
Provide a succinct answer. 0.7. What is the ratio of the Value added (current US$) of Liberia in 1985 to that in 1989?
Offer a terse response. 1.27. What is the ratio of the Value added (current US$) of Syrian Arab Republic in 1985 to that in 1989?
Provide a short and direct response. 1.54. What is the ratio of the Value added (current US$) of Tunisia in 1985 to that in 1989?
Your answer should be compact. 0.88. What is the ratio of the Value added (current US$) of Other small states in 1985 to that in 1990?
Offer a terse response. 0.56. What is the ratio of the Value added (current US$) of Liberia in 1985 to that in 1990?
Your response must be concise. 3.65. What is the ratio of the Value added (current US$) of Syrian Arab Republic in 1985 to that in 1990?
Provide a succinct answer. 1.22. What is the ratio of the Value added (current US$) of Tunisia in 1985 to that in 1990?
Keep it short and to the point. 0.75. What is the ratio of the Value added (current US$) in Other small states in 1985 to that in 1991?
Your answer should be compact. 0.57. What is the ratio of the Value added (current US$) in Liberia in 1985 to that in 1991?
Offer a very short reply. 4.05. What is the ratio of the Value added (current US$) in Syrian Arab Republic in 1985 to that in 1991?
Make the answer very short. 1.28. What is the ratio of the Value added (current US$) in Tunisia in 1985 to that in 1991?
Your answer should be compact. 0.73. What is the ratio of the Value added (current US$) in Other small states in 1985 to that in 1992?
Give a very brief answer. 0.54. What is the ratio of the Value added (current US$) of Liberia in 1985 to that in 1992?
Ensure brevity in your answer.  6.76. What is the ratio of the Value added (current US$) in Syrian Arab Republic in 1985 to that in 1992?
Your answer should be very brief. 1.58. What is the ratio of the Value added (current US$) in Tunisia in 1985 to that in 1992?
Offer a very short reply. 0.62. What is the ratio of the Value added (current US$) of Other small states in 1986 to that in 1987?
Your answer should be compact. 0.86. What is the ratio of the Value added (current US$) of Liberia in 1986 to that in 1987?
Your answer should be very brief. 1.03. What is the ratio of the Value added (current US$) of Syrian Arab Republic in 1986 to that in 1987?
Your answer should be very brief. 1.34. What is the ratio of the Value added (current US$) of Tunisia in 1986 to that in 1987?
Give a very brief answer. 0.96. What is the ratio of the Value added (current US$) in Other small states in 1986 to that in 1988?
Provide a succinct answer. 0.76. What is the ratio of the Value added (current US$) of Liberia in 1986 to that in 1988?
Provide a short and direct response. 0.94. What is the ratio of the Value added (current US$) in Syrian Arab Republic in 1986 to that in 1988?
Your response must be concise. 1.39. What is the ratio of the Value added (current US$) of Tunisia in 1986 to that in 1988?
Your answer should be compact. 0.89. What is the ratio of the Value added (current US$) of Other small states in 1986 to that in 1989?
Provide a short and direct response. 0.67. What is the ratio of the Value added (current US$) in Liberia in 1986 to that in 1989?
Provide a short and direct response. 1.25. What is the ratio of the Value added (current US$) of Syrian Arab Republic in 1986 to that in 1989?
Offer a terse response. 1.27. What is the ratio of the Value added (current US$) of Tunisia in 1986 to that in 1989?
Your response must be concise. 0.87. What is the ratio of the Value added (current US$) in Other small states in 1986 to that in 1990?
Your answer should be very brief. 0.53. What is the ratio of the Value added (current US$) of Liberia in 1986 to that in 1990?
Provide a short and direct response. 3.62. What is the ratio of the Value added (current US$) of Syrian Arab Republic in 1986 to that in 1990?
Provide a short and direct response. 1.01. What is the ratio of the Value added (current US$) in Tunisia in 1986 to that in 1990?
Provide a short and direct response. 0.75. What is the ratio of the Value added (current US$) of Other small states in 1986 to that in 1991?
Your answer should be very brief. 0.54. What is the ratio of the Value added (current US$) of Liberia in 1986 to that in 1991?
Your response must be concise. 4.01. What is the ratio of the Value added (current US$) in Syrian Arab Republic in 1986 to that in 1991?
Provide a succinct answer. 1.06. What is the ratio of the Value added (current US$) of Tunisia in 1986 to that in 1991?
Provide a short and direct response. 0.73. What is the ratio of the Value added (current US$) of Other small states in 1986 to that in 1992?
Give a very brief answer. 0.52. What is the ratio of the Value added (current US$) in Liberia in 1986 to that in 1992?
Keep it short and to the point. 6.69. What is the ratio of the Value added (current US$) in Syrian Arab Republic in 1986 to that in 1992?
Provide a succinct answer. 1.3. What is the ratio of the Value added (current US$) of Tunisia in 1986 to that in 1992?
Keep it short and to the point. 0.62. What is the ratio of the Value added (current US$) in Other small states in 1987 to that in 1988?
Give a very brief answer. 0.89. What is the ratio of the Value added (current US$) of Liberia in 1987 to that in 1988?
Provide a short and direct response. 0.91. What is the ratio of the Value added (current US$) in Syrian Arab Republic in 1987 to that in 1988?
Make the answer very short. 1.04. What is the ratio of the Value added (current US$) in Tunisia in 1987 to that in 1988?
Provide a short and direct response. 0.93. What is the ratio of the Value added (current US$) of Other small states in 1987 to that in 1989?
Ensure brevity in your answer.  0.78. What is the ratio of the Value added (current US$) in Liberia in 1987 to that in 1989?
Provide a short and direct response. 1.21. What is the ratio of the Value added (current US$) of Syrian Arab Republic in 1987 to that in 1989?
Give a very brief answer. 0.94. What is the ratio of the Value added (current US$) of Tunisia in 1987 to that in 1989?
Your response must be concise. 0.91. What is the ratio of the Value added (current US$) of Other small states in 1987 to that in 1990?
Offer a very short reply. 0.63. What is the ratio of the Value added (current US$) in Liberia in 1987 to that in 1990?
Your response must be concise. 3.5. What is the ratio of the Value added (current US$) of Syrian Arab Republic in 1987 to that in 1990?
Your response must be concise. 0.75. What is the ratio of the Value added (current US$) in Tunisia in 1987 to that in 1990?
Give a very brief answer. 0.78. What is the ratio of the Value added (current US$) in Other small states in 1987 to that in 1991?
Your answer should be compact. 0.63. What is the ratio of the Value added (current US$) of Liberia in 1987 to that in 1991?
Offer a terse response. 3.88. What is the ratio of the Value added (current US$) in Syrian Arab Republic in 1987 to that in 1991?
Make the answer very short. 0.79. What is the ratio of the Value added (current US$) of Tunisia in 1987 to that in 1991?
Offer a terse response. 0.75. What is the ratio of the Value added (current US$) in Other small states in 1987 to that in 1992?
Give a very brief answer. 0.6. What is the ratio of the Value added (current US$) of Liberia in 1987 to that in 1992?
Ensure brevity in your answer.  6.48. What is the ratio of the Value added (current US$) in Syrian Arab Republic in 1987 to that in 1992?
Keep it short and to the point. 0.97. What is the ratio of the Value added (current US$) of Tunisia in 1987 to that in 1992?
Your response must be concise. 0.65. What is the ratio of the Value added (current US$) of Other small states in 1988 to that in 1989?
Provide a succinct answer. 0.88. What is the ratio of the Value added (current US$) of Liberia in 1988 to that in 1989?
Provide a succinct answer. 1.33. What is the ratio of the Value added (current US$) in Syrian Arab Republic in 1988 to that in 1989?
Give a very brief answer. 0.91. What is the ratio of the Value added (current US$) in Tunisia in 1988 to that in 1989?
Keep it short and to the point. 0.98. What is the ratio of the Value added (current US$) in Other small states in 1988 to that in 1990?
Offer a very short reply. 0.7. What is the ratio of the Value added (current US$) in Liberia in 1988 to that in 1990?
Ensure brevity in your answer.  3.84. What is the ratio of the Value added (current US$) of Syrian Arab Republic in 1988 to that in 1990?
Your answer should be very brief. 0.72. What is the ratio of the Value added (current US$) in Tunisia in 1988 to that in 1990?
Your response must be concise. 0.84. What is the ratio of the Value added (current US$) of Other small states in 1988 to that in 1991?
Provide a short and direct response. 0.71. What is the ratio of the Value added (current US$) in Liberia in 1988 to that in 1991?
Give a very brief answer. 4.25. What is the ratio of the Value added (current US$) in Syrian Arab Republic in 1988 to that in 1991?
Your answer should be compact. 0.76. What is the ratio of the Value added (current US$) of Tunisia in 1988 to that in 1991?
Keep it short and to the point. 0.82. What is the ratio of the Value added (current US$) in Other small states in 1988 to that in 1992?
Offer a very short reply. 0.68. What is the ratio of the Value added (current US$) of Liberia in 1988 to that in 1992?
Provide a succinct answer. 7.1. What is the ratio of the Value added (current US$) of Syrian Arab Republic in 1988 to that in 1992?
Give a very brief answer. 0.93. What is the ratio of the Value added (current US$) of Tunisia in 1988 to that in 1992?
Your answer should be compact. 0.7. What is the ratio of the Value added (current US$) of Other small states in 1989 to that in 1990?
Make the answer very short. 0.8. What is the ratio of the Value added (current US$) in Liberia in 1989 to that in 1990?
Ensure brevity in your answer.  2.88. What is the ratio of the Value added (current US$) of Syrian Arab Republic in 1989 to that in 1990?
Your answer should be very brief. 0.79. What is the ratio of the Value added (current US$) in Tunisia in 1989 to that in 1990?
Provide a short and direct response. 0.86. What is the ratio of the Value added (current US$) of Other small states in 1989 to that in 1991?
Offer a very short reply. 0.81. What is the ratio of the Value added (current US$) in Liberia in 1989 to that in 1991?
Your answer should be compact. 3.19. What is the ratio of the Value added (current US$) in Syrian Arab Republic in 1989 to that in 1991?
Your answer should be compact. 0.83. What is the ratio of the Value added (current US$) in Tunisia in 1989 to that in 1991?
Provide a short and direct response. 0.83. What is the ratio of the Value added (current US$) of Other small states in 1989 to that in 1992?
Your answer should be very brief. 0.78. What is the ratio of the Value added (current US$) of Liberia in 1989 to that in 1992?
Offer a terse response. 5.34. What is the ratio of the Value added (current US$) in Syrian Arab Republic in 1989 to that in 1992?
Make the answer very short. 1.03. What is the ratio of the Value added (current US$) of Tunisia in 1989 to that in 1992?
Your response must be concise. 0.71. What is the ratio of the Value added (current US$) in Other small states in 1990 to that in 1991?
Provide a succinct answer. 1.01. What is the ratio of the Value added (current US$) of Liberia in 1990 to that in 1991?
Keep it short and to the point. 1.11. What is the ratio of the Value added (current US$) in Syrian Arab Republic in 1990 to that in 1991?
Provide a short and direct response. 1.05. What is the ratio of the Value added (current US$) of Tunisia in 1990 to that in 1991?
Make the answer very short. 0.97. What is the ratio of the Value added (current US$) in Other small states in 1990 to that in 1992?
Make the answer very short. 0.97. What is the ratio of the Value added (current US$) in Liberia in 1990 to that in 1992?
Ensure brevity in your answer.  1.85. What is the ratio of the Value added (current US$) in Syrian Arab Republic in 1990 to that in 1992?
Give a very brief answer. 1.29. What is the ratio of the Value added (current US$) of Tunisia in 1990 to that in 1992?
Your response must be concise. 0.83. What is the ratio of the Value added (current US$) of Other small states in 1991 to that in 1992?
Offer a terse response. 0.96. What is the ratio of the Value added (current US$) of Liberia in 1991 to that in 1992?
Your answer should be compact. 1.67. What is the ratio of the Value added (current US$) in Syrian Arab Republic in 1991 to that in 1992?
Provide a short and direct response. 1.23. What is the ratio of the Value added (current US$) of Tunisia in 1991 to that in 1992?
Offer a terse response. 0.86. What is the difference between the highest and the second highest Value added (current US$) in Other small states?
Provide a short and direct response. 3.91e+08. What is the difference between the highest and the second highest Value added (current US$) in Liberia?
Your response must be concise. 1.18e+07. What is the difference between the highest and the second highest Value added (current US$) of Syrian Arab Republic?
Provide a succinct answer. 6.37e+08. What is the difference between the highest and the second highest Value added (current US$) in Tunisia?
Offer a terse response. 6.22e+08. What is the difference between the highest and the lowest Value added (current US$) in Other small states?
Offer a very short reply. 5.51e+09. What is the difference between the highest and the lowest Value added (current US$) in Liberia?
Provide a succinct answer. 2.13e+08. What is the difference between the highest and the lowest Value added (current US$) in Syrian Arab Republic?
Make the answer very short. 1.48e+09. What is the difference between the highest and the lowest Value added (current US$) of Tunisia?
Your response must be concise. 1.66e+09. 